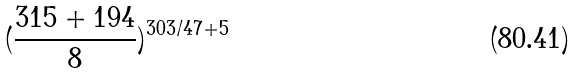<formula> <loc_0><loc_0><loc_500><loc_500>( \frac { 3 1 5 + 1 9 4 } { 8 } ) ^ { 3 0 3 / 4 7 + 5 }</formula> 